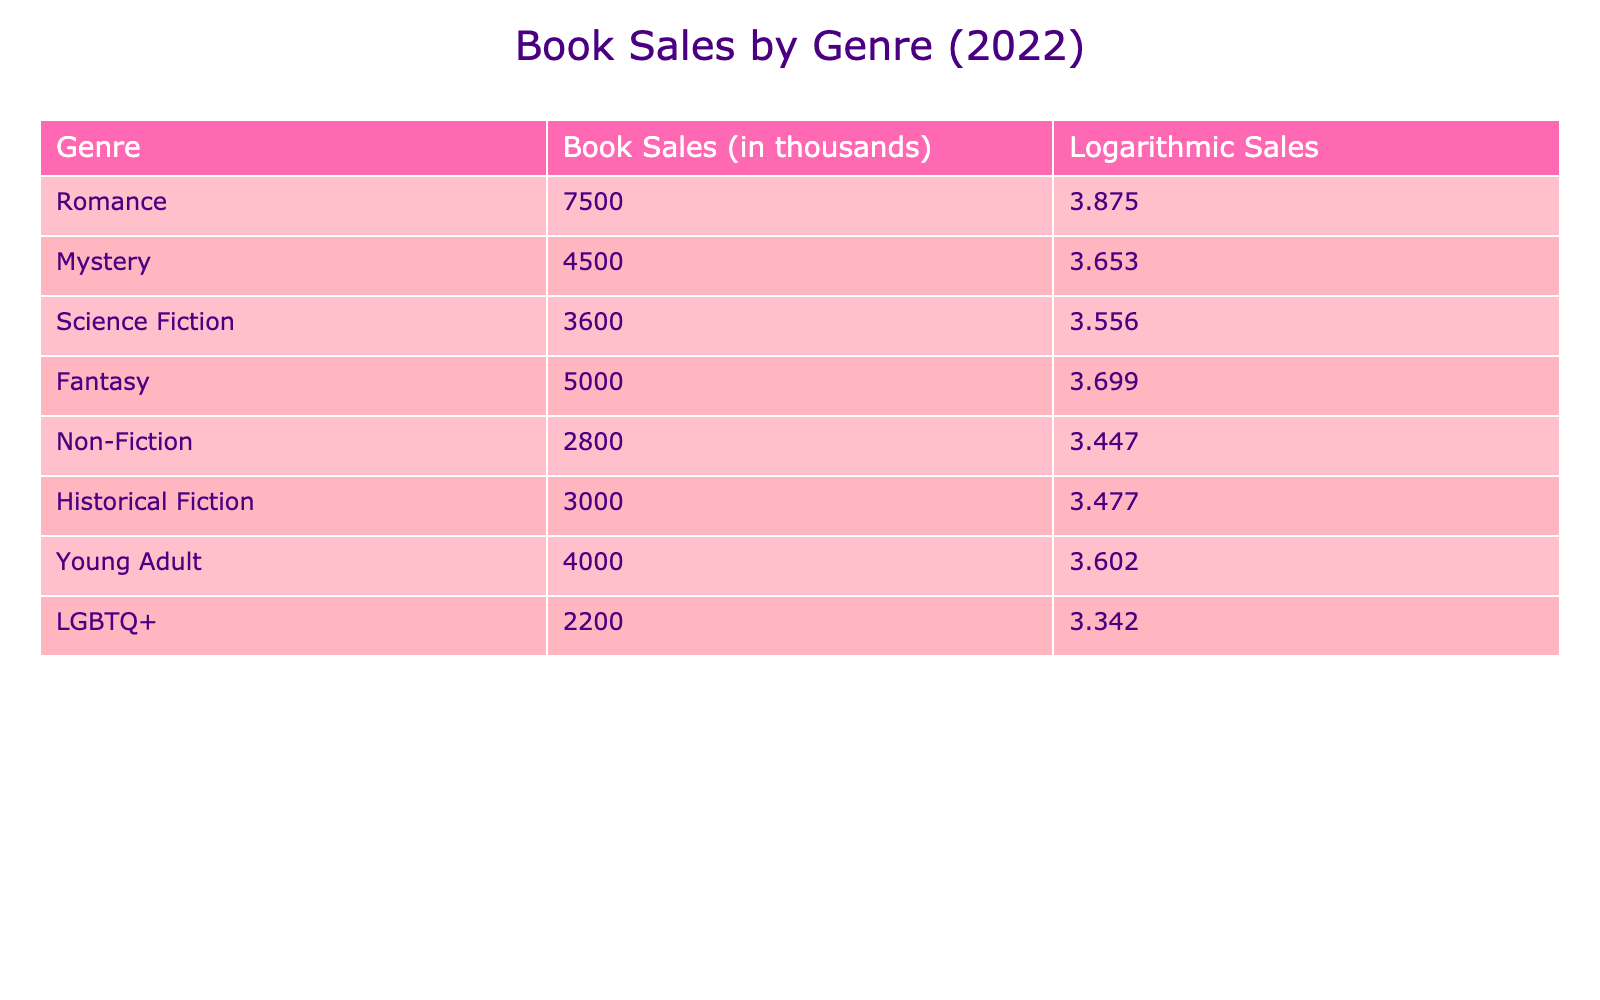What is the book sales value for the Romance genre? The table shows the book sales in thousands for each genre. In the row for Romance, the value is directly listed as 7500.
Answer: 7500 Which genre has the lowest book sales? By examining the book sales values in the table, LGBTQ+ has the lowest sales at 2200.
Answer: LGBTQ+ What is the difference in book sales between Fantasy and Science Fiction? The book sales for Fantasy are 5000 and Science Fiction are 3600. The difference is calculated as 5000 - 3600 = 1400.
Answer: 1400 What is the total book sales of both Non-Fiction and Historical Fiction? Non-Fiction sales are 2800 and Historical Fiction sales are 3000. To find the total, we sum these values: 2800 + 3000 = 5800.
Answer: 5800 Is it true that the book sales for Young Adult are greater than those for Mystery? Young Adult sales are 4000 and Mystery sales are 4500. Since 4000 is less than 4500, the statement is false.
Answer: No What is the average book sales across all genres? To find the average, sum all the book sales: 7500 + 4500 + 3600 + 5000 + 2800 + 3000 + 4000 + 2200 = 27600. Since there are 8 genres, the average is 27600 / 8 = 3450.
Answer: 3450 Which genre's book sales are logarithmically highest? Looking at the logarithmic sales column, Romance has the highest value at 3.875, indicating it has the highest book sales.
Answer: Romance How many genres have book sales above 4000? The genres with sales above 4000 are Romance, Fantasy, and Young Adult. Counting these gives us a total of 3 genres.
Answer: 3 What is the total book sales for genres with less than 3000 sales? The genres with less than 3000 sales are Non-Fiction (2800) and LGBTQ+ (2200). Their total sales are 2800 + 2200 = 5000.
Answer: 5000 